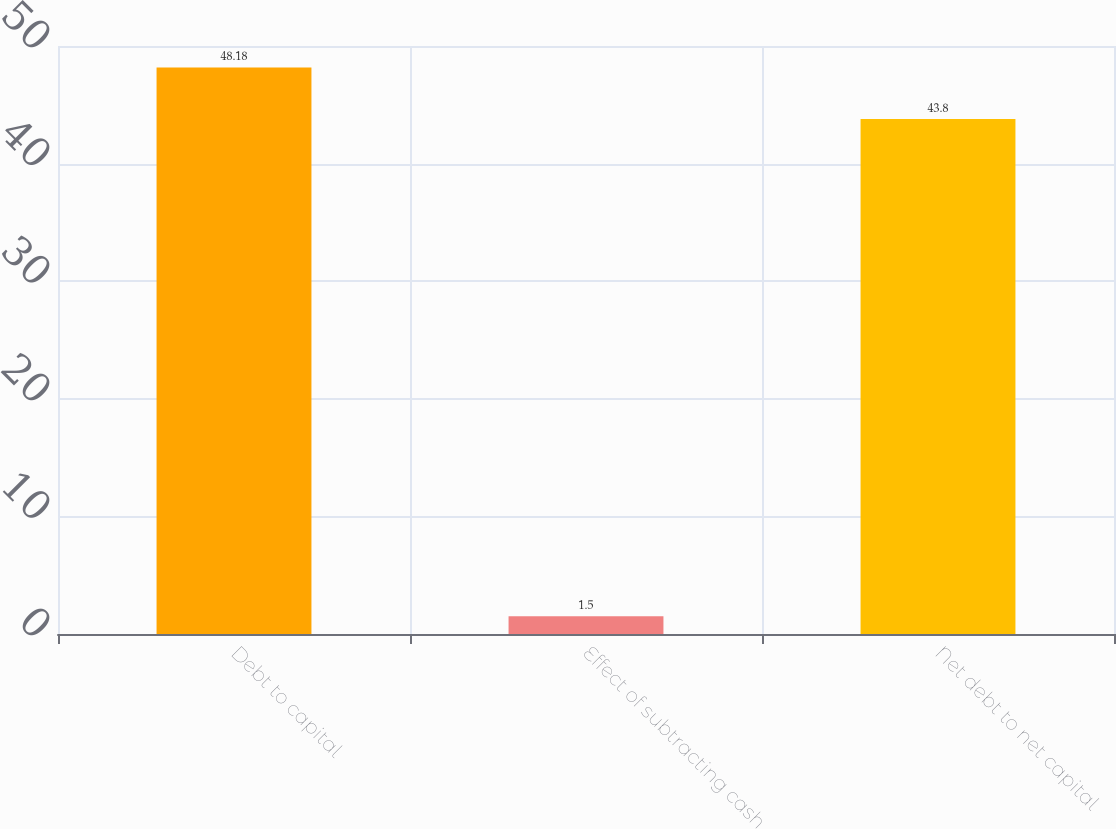<chart> <loc_0><loc_0><loc_500><loc_500><bar_chart><fcel>Debt to capital<fcel>Effect of subtracting cash<fcel>Net debt to net capital<nl><fcel>48.18<fcel>1.5<fcel>43.8<nl></chart> 